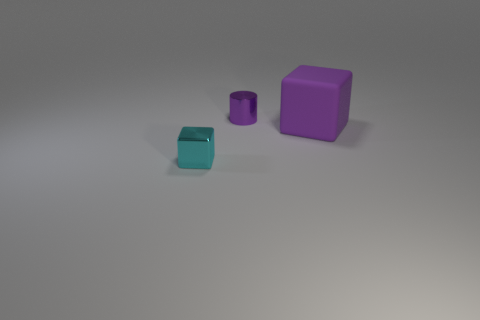The thing that is the same color as the large block is what size?
Make the answer very short. Small. Is there another thing that has the same shape as the cyan thing?
Make the answer very short. Yes. What number of things are yellow rubber balls or purple things?
Give a very brief answer. 2. What number of big cubes are to the right of the shiny object in front of the purple metal cylinder behind the purple matte thing?
Ensure brevity in your answer.  1. What material is the other thing that is the same shape as the small cyan shiny object?
Keep it short and to the point. Rubber. There is a object that is both in front of the metallic cylinder and on the left side of the big block; what is it made of?
Your answer should be very brief. Metal. Is the number of cyan things that are left of the tiny cyan object less than the number of tiny shiny things behind the rubber thing?
Offer a terse response. Yes. What number of other things are there of the same size as the purple rubber cube?
Make the answer very short. 0. What is the shape of the tiny metallic thing that is in front of the small shiny object that is right of the cube left of the purple rubber thing?
Offer a very short reply. Cube. How many purple things are either small metallic objects or tiny metallic cubes?
Ensure brevity in your answer.  1. 